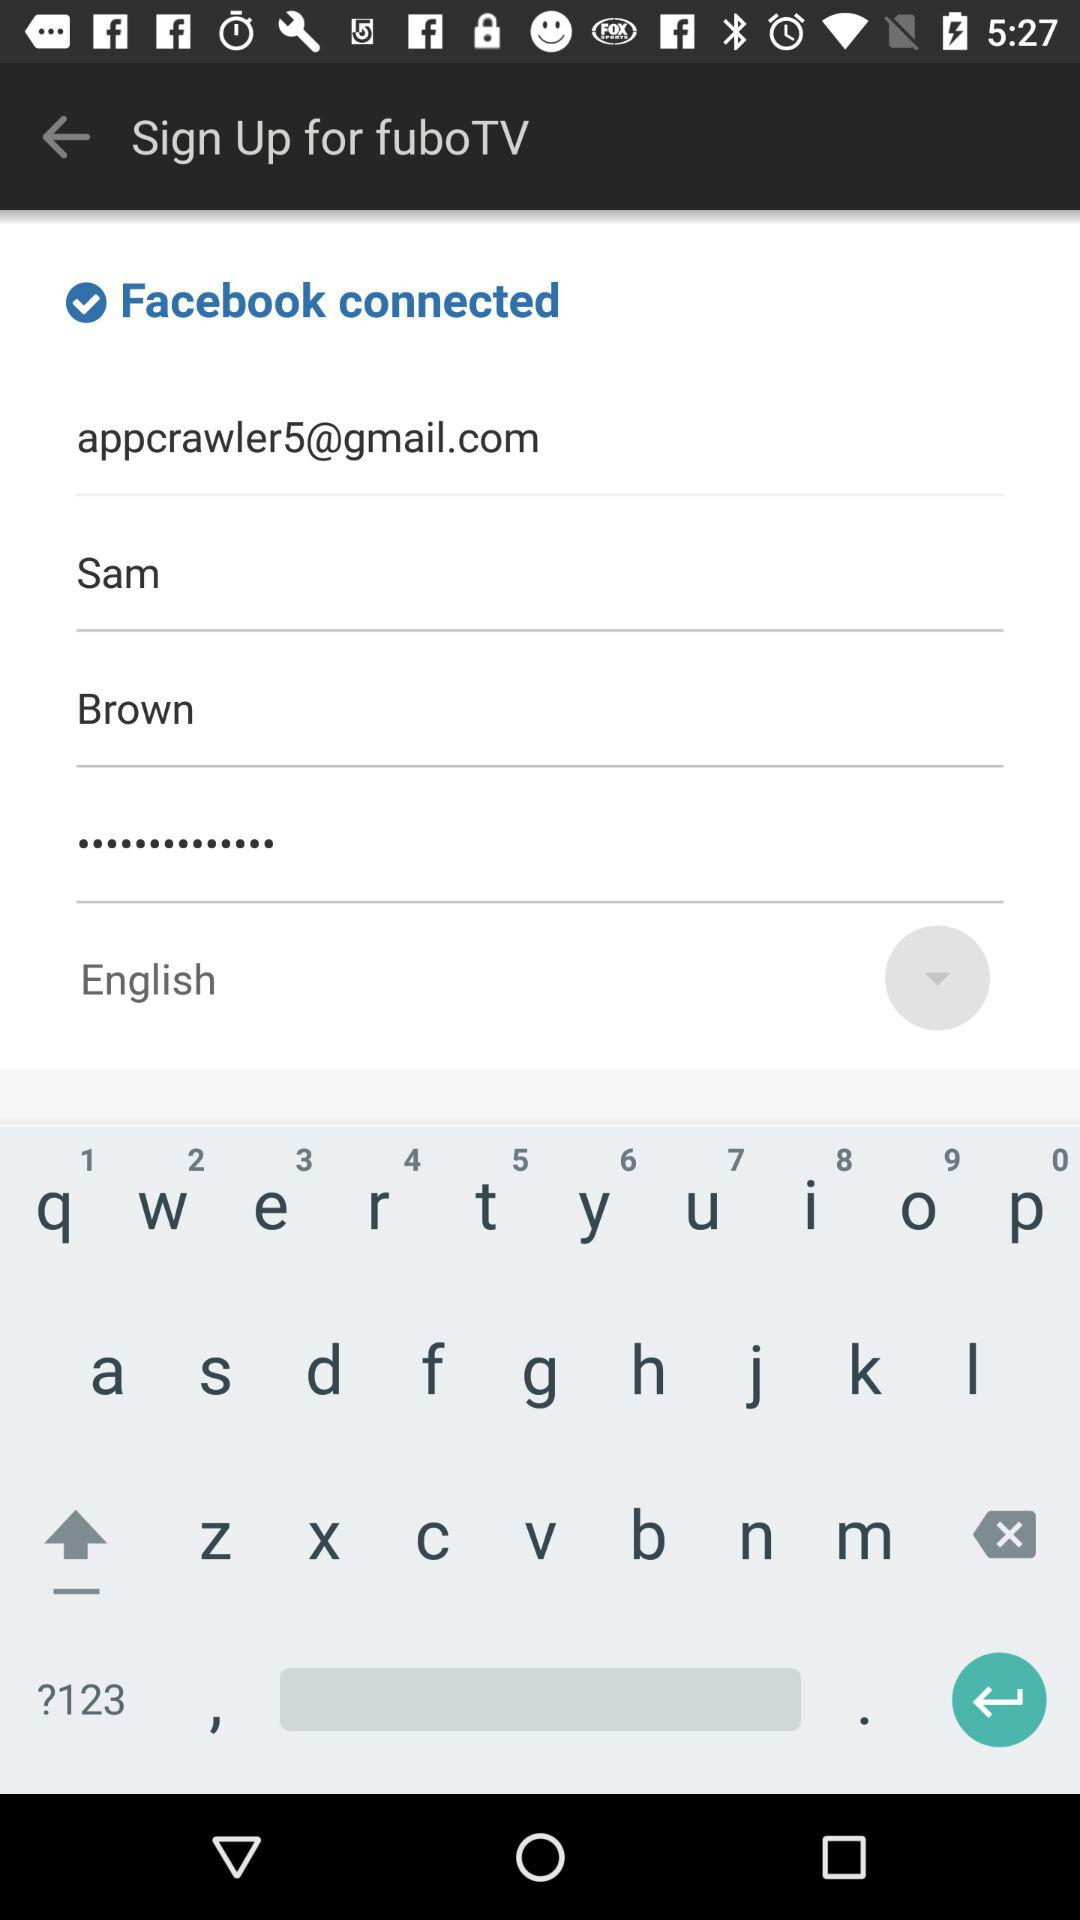What is the email address? The email address is appcrawler5@gmail.com. 